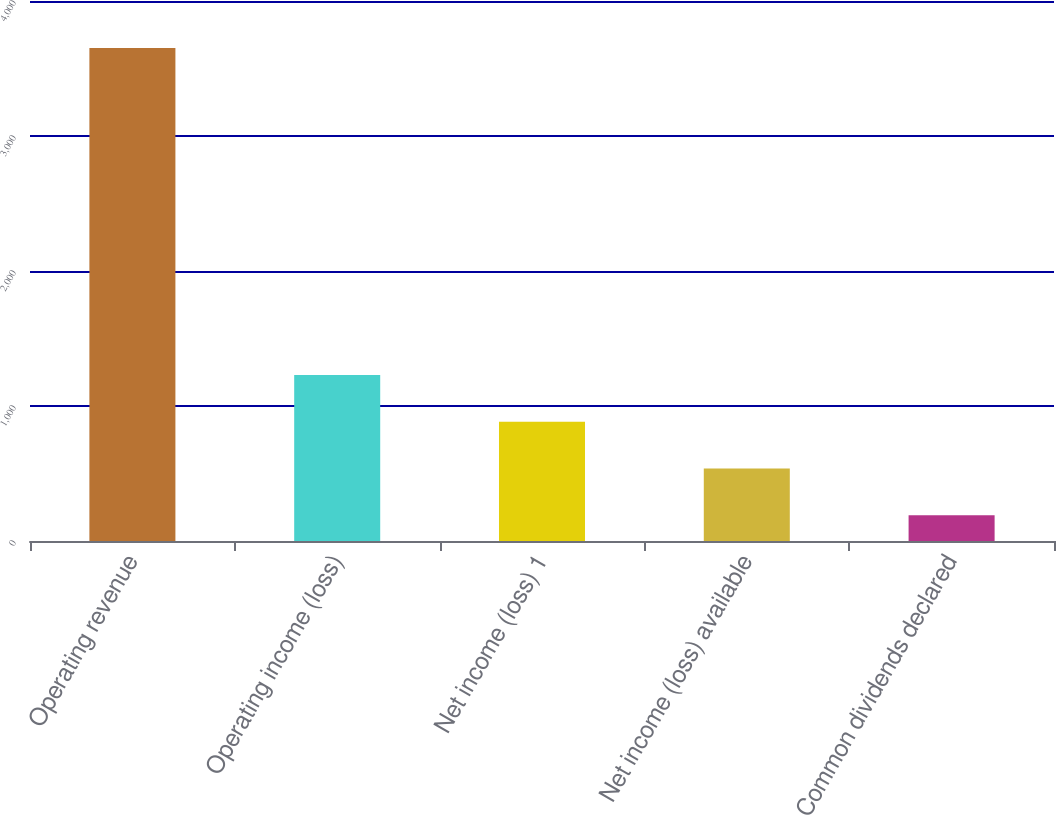Convert chart to OTSL. <chart><loc_0><loc_0><loc_500><loc_500><bar_chart><fcel>Operating revenue<fcel>Operating income (loss)<fcel>Net income (loss) 1<fcel>Net income (loss) available<fcel>Common dividends declared<nl><fcel>3652<fcel>1229.3<fcel>883.2<fcel>537.1<fcel>191<nl></chart> 